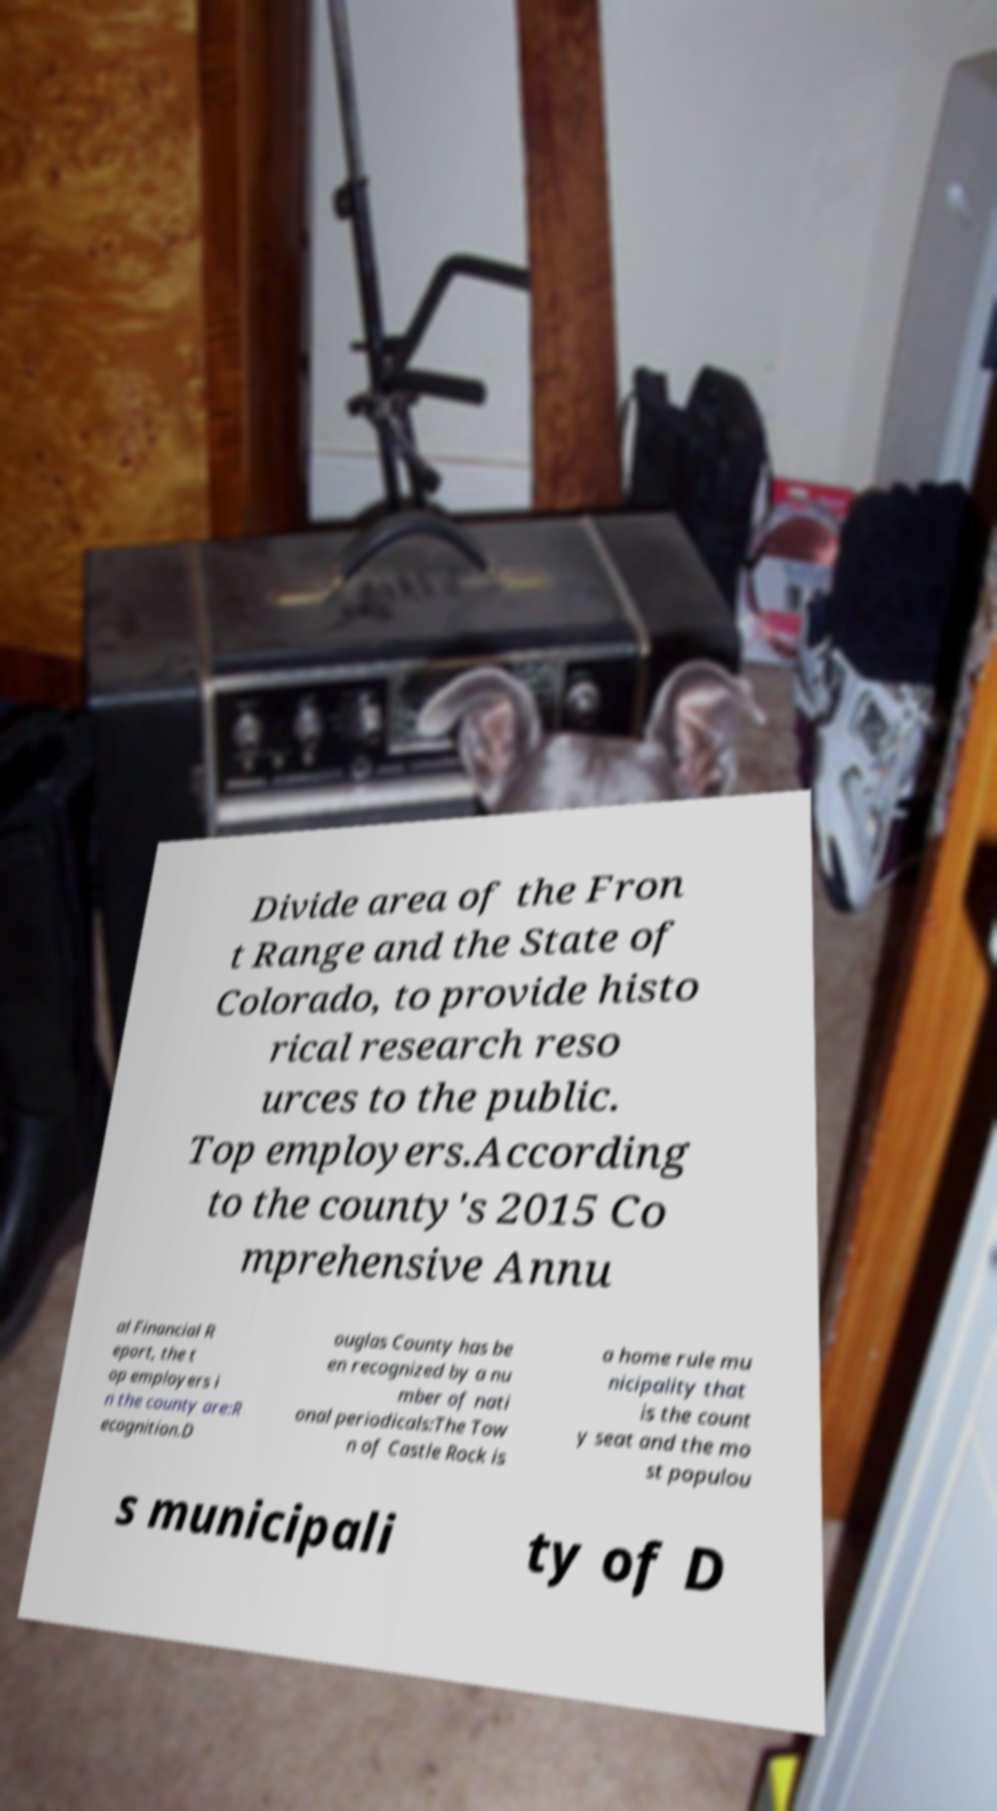Please identify and transcribe the text found in this image. Divide area of the Fron t Range and the State of Colorado, to provide histo rical research reso urces to the public. Top employers.According to the county's 2015 Co mprehensive Annu al Financial R eport, the t op employers i n the county are:R ecognition.D ouglas County has be en recognized by a nu mber of nati onal periodicals:The Tow n of Castle Rock is a home rule mu nicipality that is the count y seat and the mo st populou s municipali ty of D 